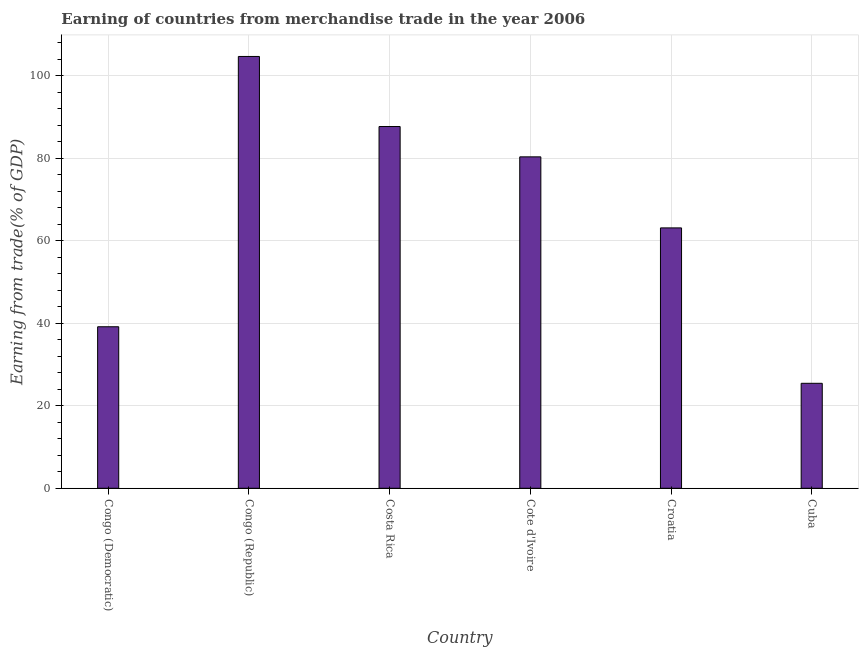Does the graph contain any zero values?
Your answer should be very brief. No. What is the title of the graph?
Give a very brief answer. Earning of countries from merchandise trade in the year 2006. What is the label or title of the Y-axis?
Your response must be concise. Earning from trade(% of GDP). What is the earning from merchandise trade in Congo (Republic)?
Your response must be concise. 104.65. Across all countries, what is the maximum earning from merchandise trade?
Provide a succinct answer. 104.65. Across all countries, what is the minimum earning from merchandise trade?
Provide a succinct answer. 25.44. In which country was the earning from merchandise trade maximum?
Make the answer very short. Congo (Republic). In which country was the earning from merchandise trade minimum?
Keep it short and to the point. Cuba. What is the sum of the earning from merchandise trade?
Offer a very short reply. 400.32. What is the difference between the earning from merchandise trade in Congo (Republic) and Cuba?
Offer a terse response. 79.21. What is the average earning from merchandise trade per country?
Your response must be concise. 66.72. What is the median earning from merchandise trade?
Make the answer very short. 71.71. In how many countries, is the earning from merchandise trade greater than 20 %?
Provide a short and direct response. 6. What is the ratio of the earning from merchandise trade in Croatia to that in Cuba?
Ensure brevity in your answer.  2.48. Is the earning from merchandise trade in Congo (Democratic) less than that in Cote d'Ivoire?
Offer a terse response. Yes. What is the difference between the highest and the second highest earning from merchandise trade?
Keep it short and to the point. 16.98. What is the difference between the highest and the lowest earning from merchandise trade?
Keep it short and to the point. 79.21. How many bars are there?
Provide a short and direct response. 6. Are all the bars in the graph horizontal?
Keep it short and to the point. No. Are the values on the major ticks of Y-axis written in scientific E-notation?
Your answer should be compact. No. What is the Earning from trade(% of GDP) in Congo (Democratic)?
Your response must be concise. 39.14. What is the Earning from trade(% of GDP) in Congo (Republic)?
Ensure brevity in your answer.  104.65. What is the Earning from trade(% of GDP) of Costa Rica?
Ensure brevity in your answer.  87.67. What is the Earning from trade(% of GDP) in Cote d'Ivoire?
Give a very brief answer. 80.32. What is the Earning from trade(% of GDP) in Croatia?
Your response must be concise. 63.1. What is the Earning from trade(% of GDP) of Cuba?
Offer a terse response. 25.44. What is the difference between the Earning from trade(% of GDP) in Congo (Democratic) and Congo (Republic)?
Keep it short and to the point. -65.5. What is the difference between the Earning from trade(% of GDP) in Congo (Democratic) and Costa Rica?
Ensure brevity in your answer.  -48.52. What is the difference between the Earning from trade(% of GDP) in Congo (Democratic) and Cote d'Ivoire?
Your answer should be compact. -41.17. What is the difference between the Earning from trade(% of GDP) in Congo (Democratic) and Croatia?
Provide a short and direct response. -23.96. What is the difference between the Earning from trade(% of GDP) in Congo (Democratic) and Cuba?
Ensure brevity in your answer.  13.71. What is the difference between the Earning from trade(% of GDP) in Congo (Republic) and Costa Rica?
Give a very brief answer. 16.98. What is the difference between the Earning from trade(% of GDP) in Congo (Republic) and Cote d'Ivoire?
Your response must be concise. 24.33. What is the difference between the Earning from trade(% of GDP) in Congo (Republic) and Croatia?
Your response must be concise. 41.54. What is the difference between the Earning from trade(% of GDP) in Congo (Republic) and Cuba?
Keep it short and to the point. 79.21. What is the difference between the Earning from trade(% of GDP) in Costa Rica and Cote d'Ivoire?
Offer a very short reply. 7.35. What is the difference between the Earning from trade(% of GDP) in Costa Rica and Croatia?
Offer a terse response. 24.56. What is the difference between the Earning from trade(% of GDP) in Costa Rica and Cuba?
Your answer should be compact. 62.23. What is the difference between the Earning from trade(% of GDP) in Cote d'Ivoire and Croatia?
Offer a very short reply. 17.22. What is the difference between the Earning from trade(% of GDP) in Cote d'Ivoire and Cuba?
Give a very brief answer. 54.88. What is the difference between the Earning from trade(% of GDP) in Croatia and Cuba?
Give a very brief answer. 37.66. What is the ratio of the Earning from trade(% of GDP) in Congo (Democratic) to that in Congo (Republic)?
Offer a terse response. 0.37. What is the ratio of the Earning from trade(% of GDP) in Congo (Democratic) to that in Costa Rica?
Provide a succinct answer. 0.45. What is the ratio of the Earning from trade(% of GDP) in Congo (Democratic) to that in Cote d'Ivoire?
Provide a succinct answer. 0.49. What is the ratio of the Earning from trade(% of GDP) in Congo (Democratic) to that in Croatia?
Offer a very short reply. 0.62. What is the ratio of the Earning from trade(% of GDP) in Congo (Democratic) to that in Cuba?
Your answer should be compact. 1.54. What is the ratio of the Earning from trade(% of GDP) in Congo (Republic) to that in Costa Rica?
Offer a very short reply. 1.19. What is the ratio of the Earning from trade(% of GDP) in Congo (Republic) to that in Cote d'Ivoire?
Offer a terse response. 1.3. What is the ratio of the Earning from trade(% of GDP) in Congo (Republic) to that in Croatia?
Give a very brief answer. 1.66. What is the ratio of the Earning from trade(% of GDP) in Congo (Republic) to that in Cuba?
Make the answer very short. 4.11. What is the ratio of the Earning from trade(% of GDP) in Costa Rica to that in Cote d'Ivoire?
Your answer should be compact. 1.09. What is the ratio of the Earning from trade(% of GDP) in Costa Rica to that in Croatia?
Offer a very short reply. 1.39. What is the ratio of the Earning from trade(% of GDP) in Costa Rica to that in Cuba?
Ensure brevity in your answer.  3.45. What is the ratio of the Earning from trade(% of GDP) in Cote d'Ivoire to that in Croatia?
Give a very brief answer. 1.27. What is the ratio of the Earning from trade(% of GDP) in Cote d'Ivoire to that in Cuba?
Give a very brief answer. 3.16. What is the ratio of the Earning from trade(% of GDP) in Croatia to that in Cuba?
Make the answer very short. 2.48. 